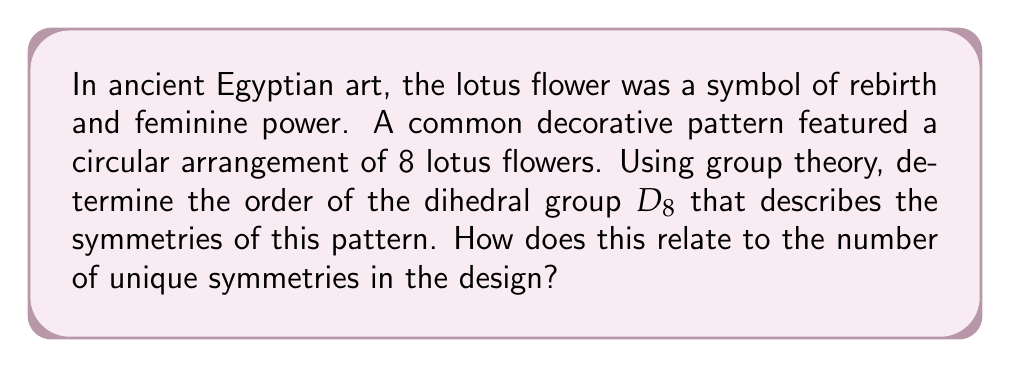Can you answer this question? To solve this problem, let's approach it step-by-step using concepts from group theory:

1) The dihedral group $D_n$ represents the symmetries of a regular n-gon. In this case, we have 8 lotus flowers arranged in a circle, so we're dealing with $D_8$.

2) The order of a dihedral group $D_n$ is given by the formula:

   $$|D_n| = 2n$$

3) For $D_8$, we have:

   $$|D_8| = 2(8) = 16$$

4) This means that the dihedral group $D_8$ has 16 elements, each representing a unique symmetry of the pattern.

5) These 16 symmetries can be broken down into:
   - 8 rotational symmetries (including the identity rotation)
   - 8 reflection symmetries

6) The rotational symmetries are:
   - Identity rotation (0°)
   - Rotations by 45°, 90°, 135°, 180°, 225°, 270°, and 315°

7) The reflection symmetries are:
   - 4 reflections across lines passing through opposite lotus flowers
   - 4 reflections across lines passing between adjacent lotus flowers

This group structure reveals the inherent balance and harmony in the ancient Egyptian design, reflecting the culture's appreciation for symmetry and order. The fact that there are an equal number of rotational and reflectional symmetries (8 each) could be seen as symbolic of the balance between different aspects of femininity and rebirth that the lotus flower represented in Egyptian culture.
Answer: The order of the dihedral group $D_8$ is 16, which corresponds to the 16 unique symmetries in the ancient Egyptian lotus flower pattern. 